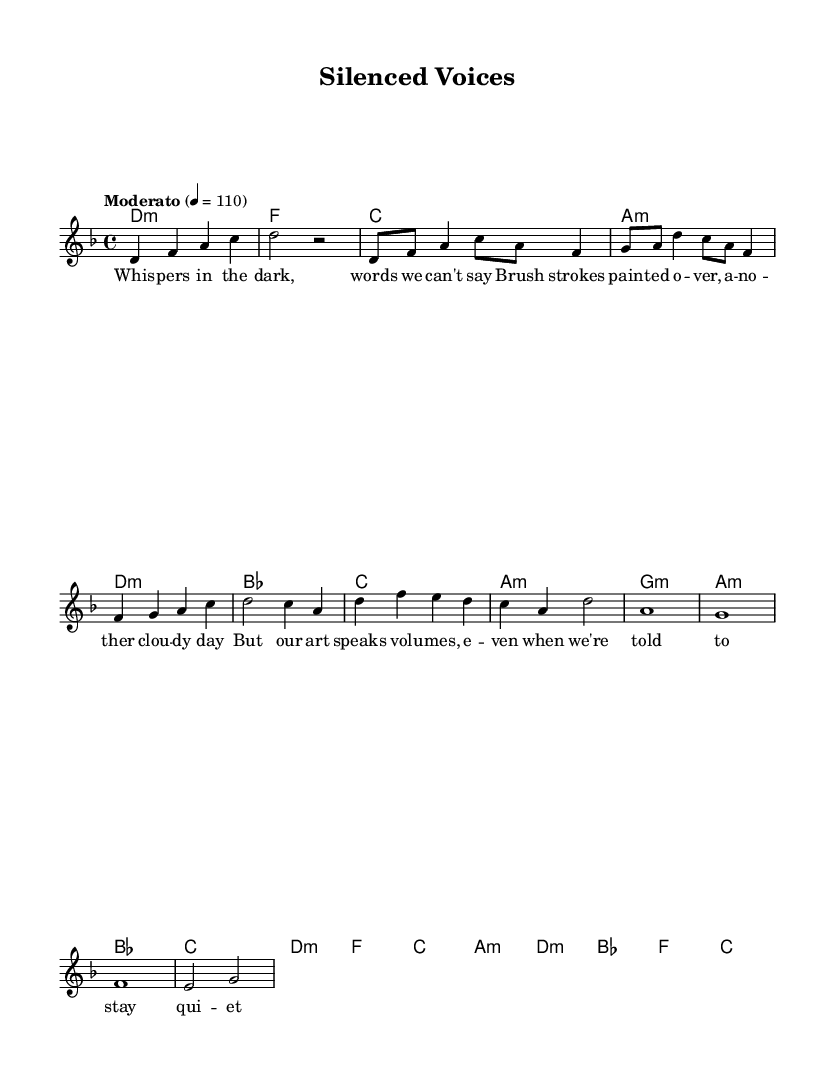What is the key signature of this music? The key signature is D minor, which has one flat (B flat). This can be identified from the "global" section where it states "\key d \minor".
Answer: D minor What is the time signature of this piece? The time signature is 4/4, which means there are four beats in each measure and the quarter note gets one beat. This is also specified in the "global" section as "\time 4/4".
Answer: 4/4 What is the tempo marking for this piece? The tempo marking is "Moderato", indicated in the "global" section with a beat of 110. It denotes a moderate speed of the piece.
Answer: Moderato How many measures are there in the chorus? The chorus consists of 4 measures. This can be determined by counting the notated measures within the chorus section of the music.
Answer: 4 What type of vocal delivery is suggested by the title "Silenced Voices"? The title suggests a contemplative or subdued vocal delivery that reflects themes of censorship and expression, typical in K-Pop's approach to sensitive topics.
Answer: Contemplative Name one of the themes expressed in the lyrics. One theme expressed in the lyrics is "censorship", which is indicated by phrases like "words we can't say" and "even when we're told to stay quiet."
Answer: Censorship 